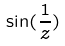<formula> <loc_0><loc_0><loc_500><loc_500>\sin ( \frac { 1 } { z } )</formula> 